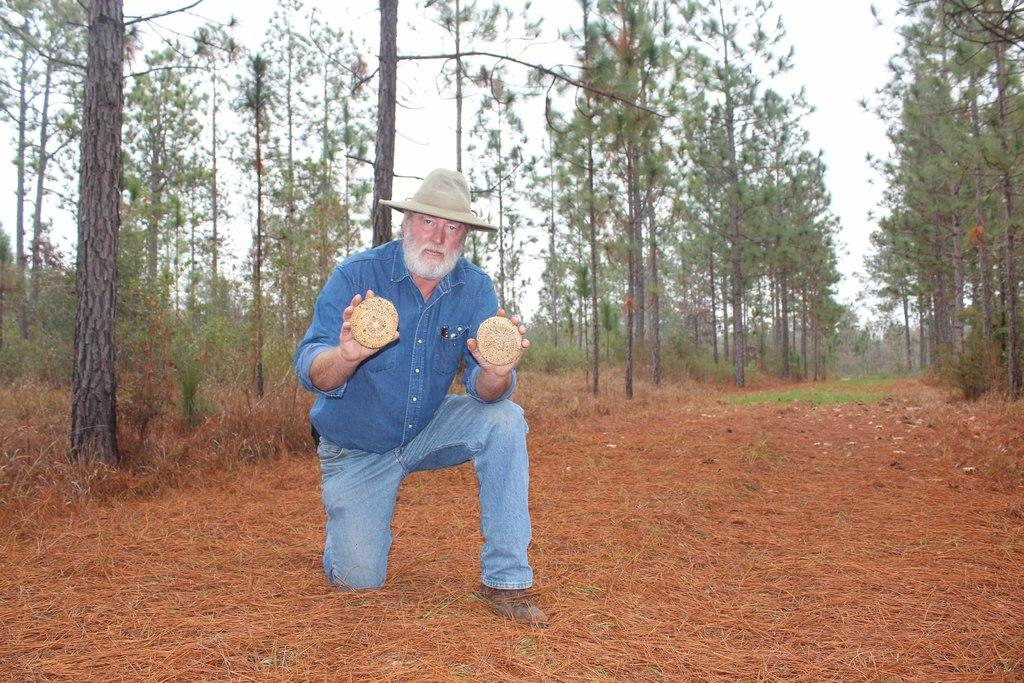What is the main subject of the image? There is a person in the image. What is the person's position in the image? The person is on the ground. What is the person wearing on their head? The person is wearing a hat. What is the person holding in the image? The person is holding some objects. What type of vegetation can be seen in the background of the image? There is dried grass in the background of the image. What else can be seen in the background of the image? There are trees and the sky visible in the background of the image. What type of drug is the person using in the image? There is no indication of any drug use in the image. The person is simply holding some objects and is not shown engaging in any activity that would suggest drug use. 